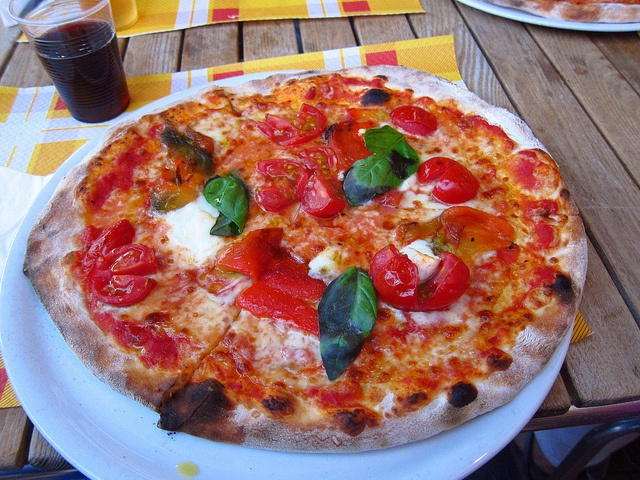Describe the objects in this image and their specific colors. I can see pizza in lavender, brown, and darkgray tones, dining table in lavender, gray, and black tones, and cup in lavender, black, navy, maroon, and darkgray tones in this image. 